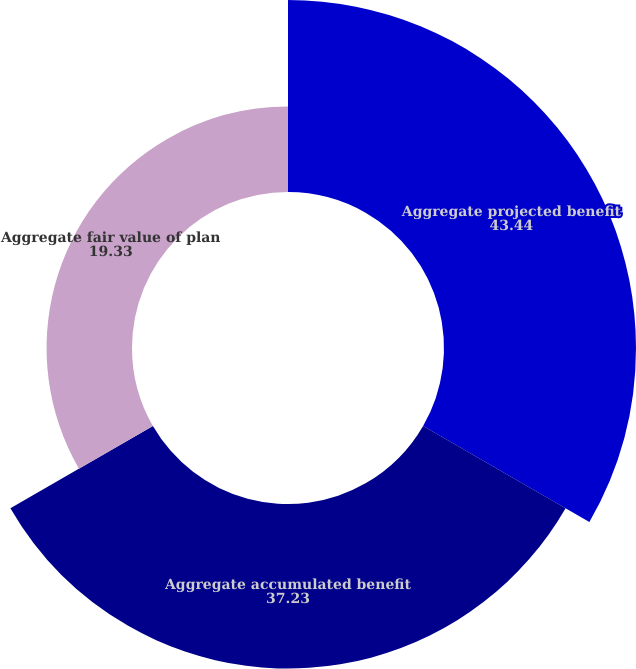Convert chart to OTSL. <chart><loc_0><loc_0><loc_500><loc_500><pie_chart><fcel>Aggregate projected benefit<fcel>Aggregate accumulated benefit<fcel>Aggregate fair value of plan<nl><fcel>43.44%<fcel>37.23%<fcel>19.33%<nl></chart> 